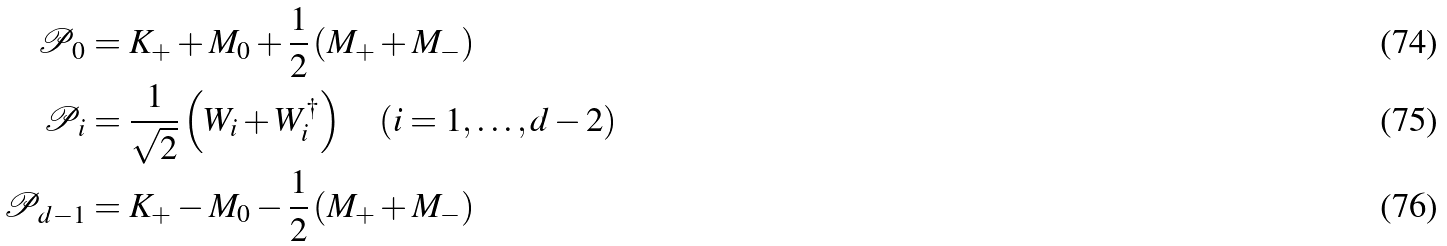<formula> <loc_0><loc_0><loc_500><loc_500>\mathcal { P } _ { 0 } & = K _ { + } + M _ { 0 } + \frac { 1 } { 2 } \left ( M _ { + } + M _ { - } \right ) \\ \mathcal { P } _ { i } & = \frac { 1 } { \sqrt { 2 } } \left ( W _ { i } + W _ { i } ^ { \dag } \right ) \quad ( i = 1 , \dots , d - 2 ) \\ \mathcal { P } _ { d - 1 } & = K _ { + } - M _ { 0 } - \frac { 1 } { 2 } \left ( M _ { + } + M _ { - } \right )</formula> 